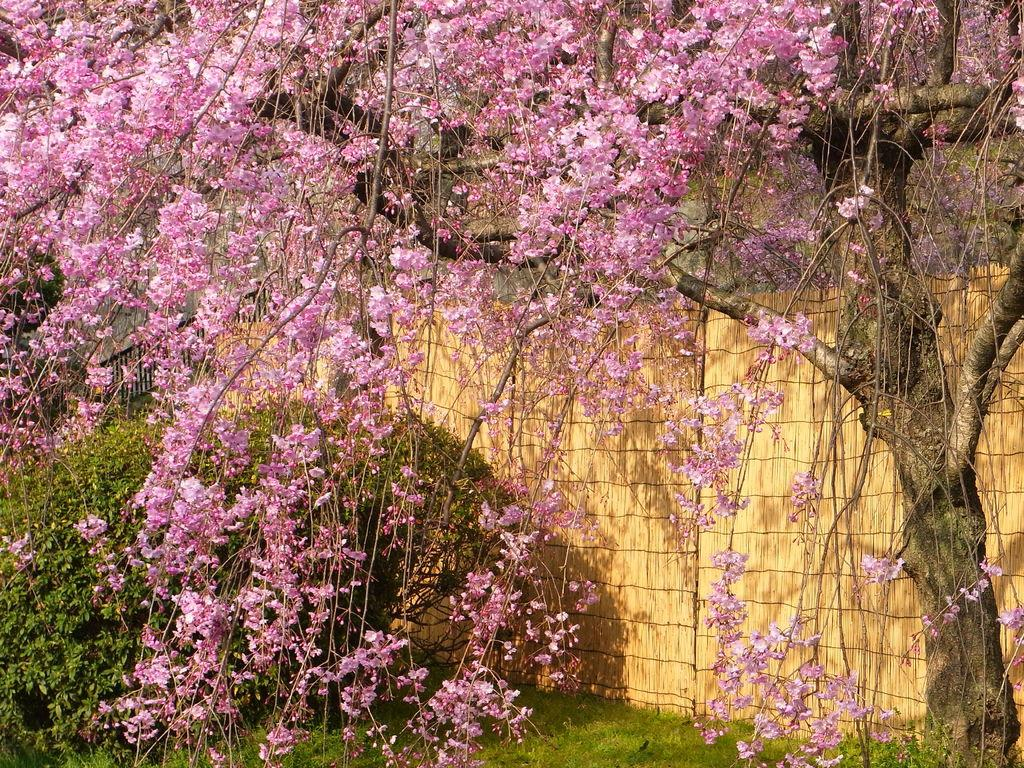What type of vegetation can be seen in the image? There are plants and a tree in the image. What color is the grass in the image? The grass in the image is green. What is the tree in the image known for? The tree in the image has pink flowers. What type of fencing is present in the image? There is light brown color fencing in the image. What type of education is being provided to the cactus in the image? There is no cactus present in the image, and therefore no education can be provided to it. What muscle is being exercised by the tree in the image? Trees do not have muscles, and the image does not depict any exercise or muscle-related activity. 